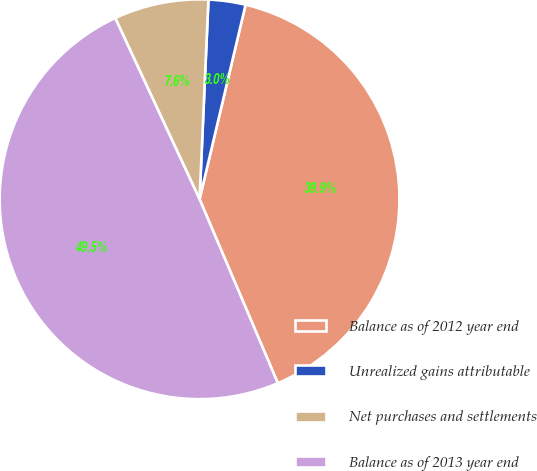Convert chart. <chart><loc_0><loc_0><loc_500><loc_500><pie_chart><fcel>Balance as of 2012 year end<fcel>Unrealized gains attributable<fcel>Net purchases and settlements<fcel>Balance as of 2013 year end<nl><fcel>39.9%<fcel>2.99%<fcel>7.64%<fcel>49.47%<nl></chart> 